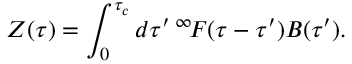<formula> <loc_0><loc_0><loc_500><loc_500>Z ( \tau ) = \int _ { 0 } ^ { \tau _ { c } } d \tau ^ { \prime } { \, ^ { \infty } \, F } ( \tau - \tau ^ { \prime } ) B ( \tau ^ { \prime } ) .</formula> 